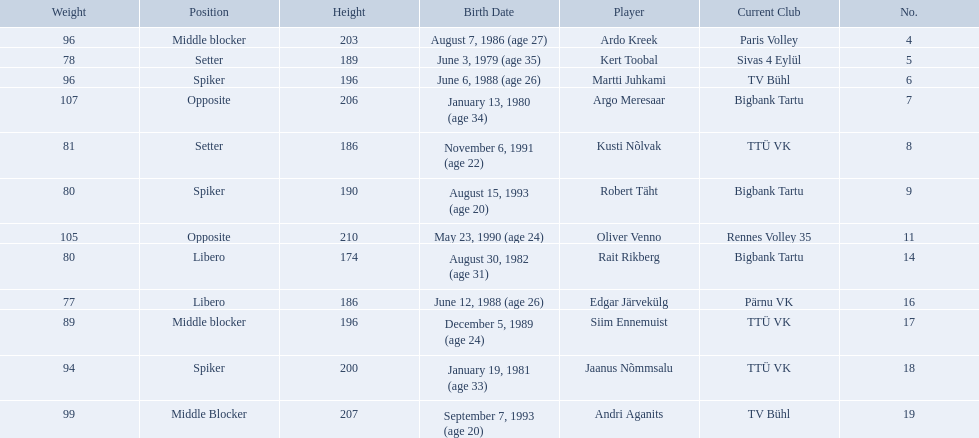Who are all of the players? Ardo Kreek, Kert Toobal, Martti Juhkami, Argo Meresaar, Kusti Nõlvak, Robert Täht, Oliver Venno, Rait Rikberg, Edgar Järvekülg, Siim Ennemuist, Jaanus Nõmmsalu, Andri Aganits. How tall are they? 203, 189, 196, 206, 186, 190, 210, 174, 186, 196, 200, 207. And which player is tallest? Oliver Venno. 